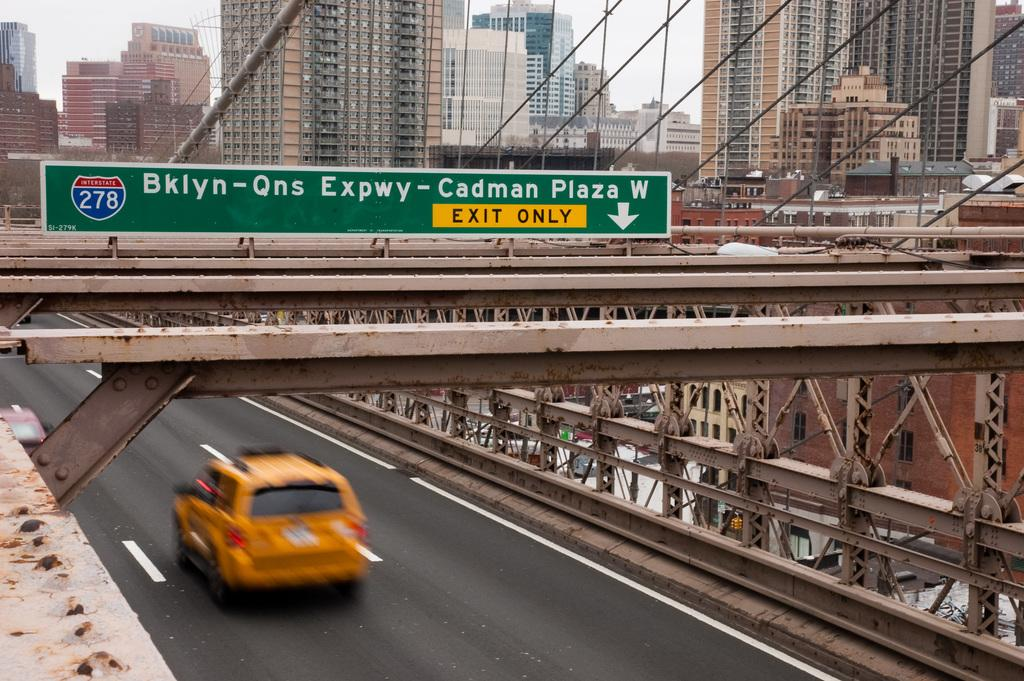Provide a one-sentence caption for the provided image. A sign over a highway that read EXIT ONLY in the yellow section. 